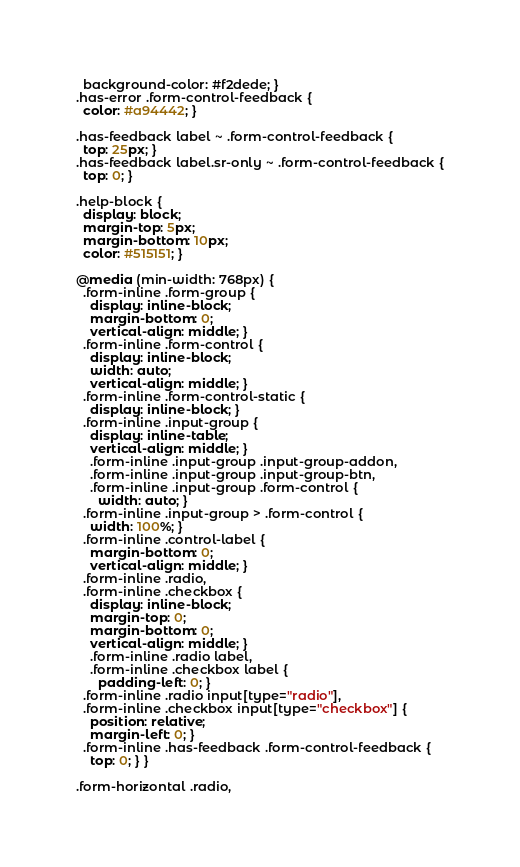<code> <loc_0><loc_0><loc_500><loc_500><_CSS_>  background-color: #f2dede; }
.has-error .form-control-feedback {
  color: #a94442; }

.has-feedback label ~ .form-control-feedback {
  top: 25px; }
.has-feedback label.sr-only ~ .form-control-feedback {
  top: 0; }

.help-block {
  display: block;
  margin-top: 5px;
  margin-bottom: 10px;
  color: #515151; }

@media (min-width: 768px) {
  .form-inline .form-group {
    display: inline-block;
    margin-bottom: 0;
    vertical-align: middle; }
  .form-inline .form-control {
    display: inline-block;
    width: auto;
    vertical-align: middle; }
  .form-inline .form-control-static {
    display: inline-block; }
  .form-inline .input-group {
    display: inline-table;
    vertical-align: middle; }
    .form-inline .input-group .input-group-addon,
    .form-inline .input-group .input-group-btn,
    .form-inline .input-group .form-control {
      width: auto; }
  .form-inline .input-group > .form-control {
    width: 100%; }
  .form-inline .control-label {
    margin-bottom: 0;
    vertical-align: middle; }
  .form-inline .radio,
  .form-inline .checkbox {
    display: inline-block;
    margin-top: 0;
    margin-bottom: 0;
    vertical-align: middle; }
    .form-inline .radio label,
    .form-inline .checkbox label {
      padding-left: 0; }
  .form-inline .radio input[type="radio"],
  .form-inline .checkbox input[type="checkbox"] {
    position: relative;
    margin-left: 0; }
  .form-inline .has-feedback .form-control-feedback {
    top: 0; } }

.form-horizontal .radio,</code> 